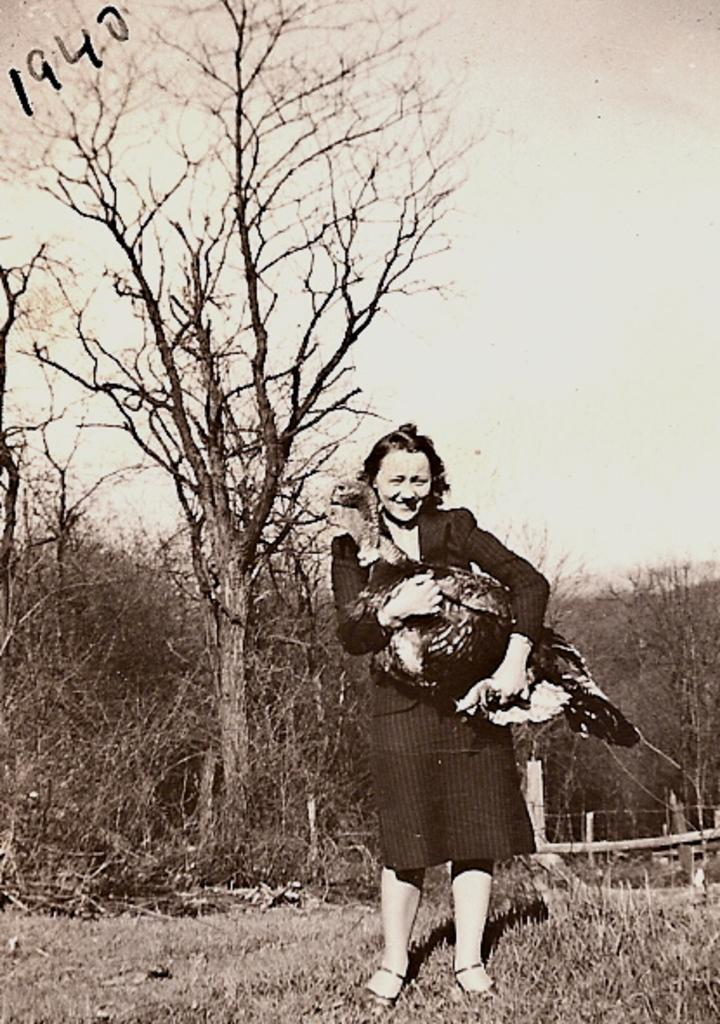Who is the main subject in the image? There is a woman in the image. What is the woman holding in the image? The woman is holding a bird. What can be seen in the background of the image? There are trees in the background of the image. What type of pain is the woman experiencing in the image? There is no indication in the image that the woman is experiencing any pain. 